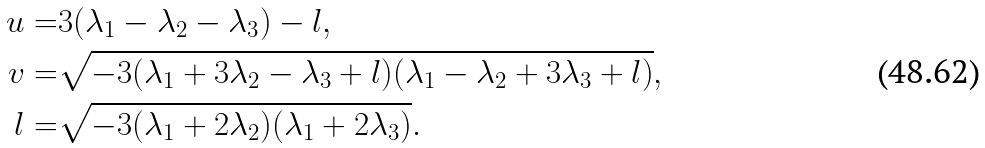<formula> <loc_0><loc_0><loc_500><loc_500>u = & 3 ( \lambda _ { 1 } - \lambda _ { 2 } - \lambda _ { 3 } ) - l , \\ v = & \sqrt { - 3 ( \lambda _ { 1 } + 3 \lambda _ { 2 } - \lambda _ { 3 } + l ) ( \lambda _ { 1 } - \lambda _ { 2 } + 3 \lambda _ { 3 } + l ) } , \\ l = & \sqrt { - 3 ( \lambda _ { 1 } + 2 \lambda _ { 2 } ) ( \lambda _ { 1 } + 2 \lambda _ { 3 } ) } .</formula> 